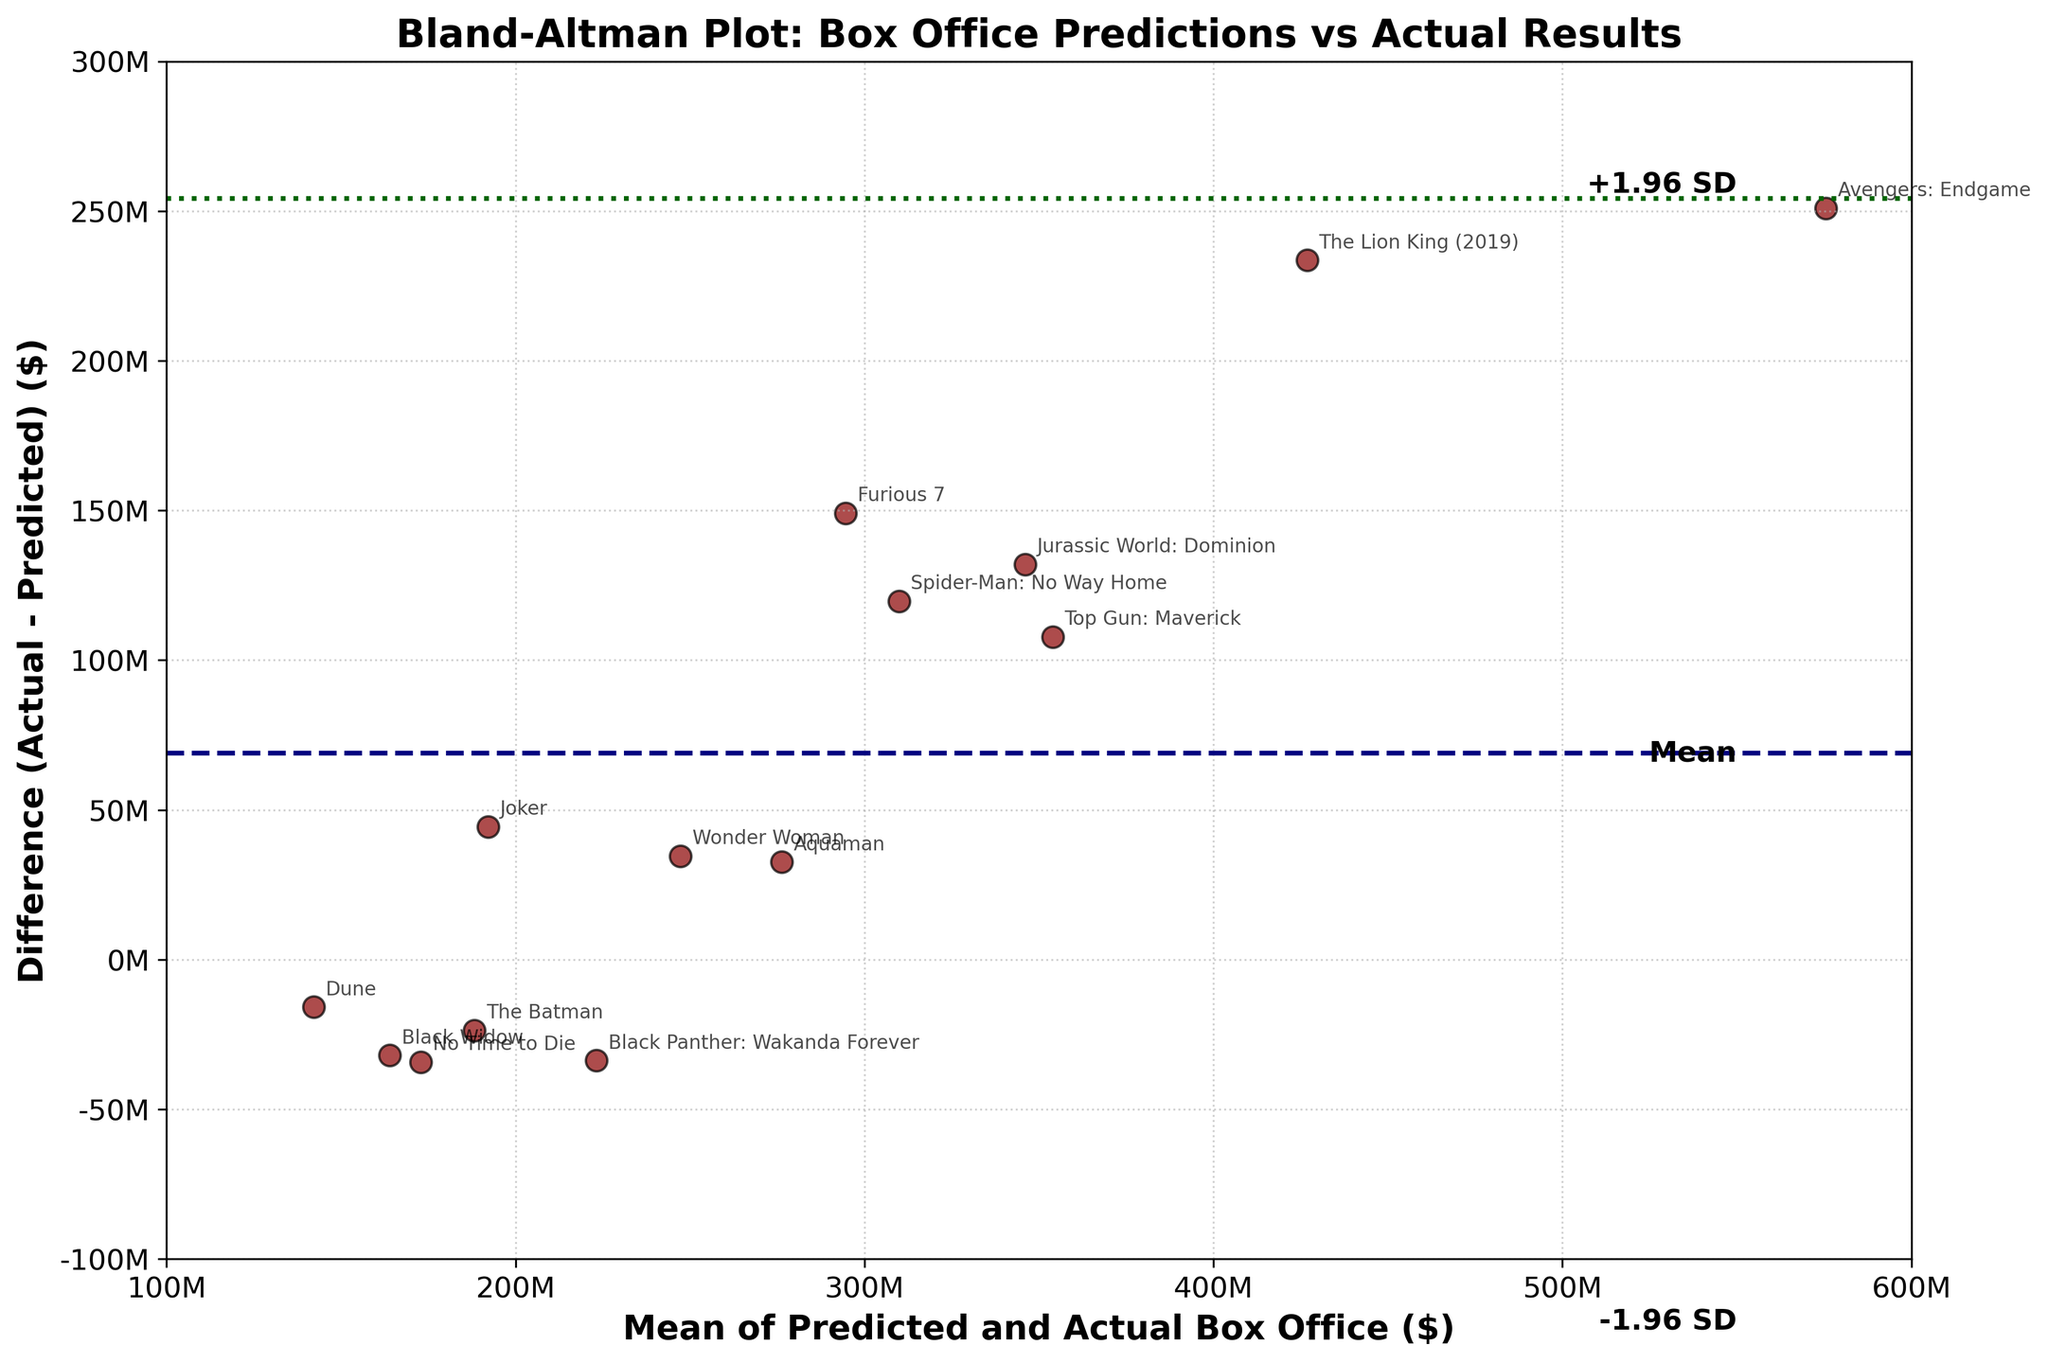What is the title of the figure? The title is located at the top of the figure, which describes what the figure represents. The title reads "Bland-Altman Plot: Box Office Predictions vs Actual Results".
Answer: Bland-Altman Plot: Box Office Predictions vs Actual Results How many movies are represented in the plot? To determine the number of movies, count the distinct scatter points in the plot. Each point represents one movie, and each point is marked with annotations of movie titles.
Answer: 14 What are the units on the x-axis and y-axis? The x-axis represents the mean of predicted and actual box office values, while the y-axis represents the difference between actual and predicted box office values. Both axes use dollars, indicated in millions ($M).
Answer: Dollars (Millions) What is the mean difference between actual and predicted box office performances? The mean difference is indicated by the horizontal navy dashed line in the plot. This line represents the average difference of the data points on the y-axis.
Answer: Approximately 53 million dollars Which movie has the largest positive difference between actual and predicted box office values? Look for the highest scatter point on the plot, as this represents the largest positive difference (actual - predicted). According to the annotation, this movie is "Avengers: Endgame".
Answer: Avengers: Endgame Which movie has the largest negative difference between actual and predicted box office values? Locate the lowest scatter point on the plot which represents the largest negative difference (actual - predicted). From reading the annotations, this movie is "Black Widow".
Answer: Black Widow How many data points lie within the +1.96 SD and -1.96 SD limits? Examine the number of scatter points between the green dotted lines that represent ±1.96 times the standard deviation from the mean difference. Count all the dots falling within these limits.
Answer: 12 What does it signify if a data point is above the green dotted line at +1.96 SD? Points above the +1.96 SD line indicate that for those movies, the actual box office performance significantly exceeded the predicted performance beyond the typical variation represented by the standard deviation.
Answer: Actual exceeds predicted by a significant margin What is the relationship between the mean box office and the actual-predicted difference for 'The Lion King (2019)'? Find the 'The Lion King (2019)' data point, then observe its position relative to both axes. Its mean box office is roughly halfway on the x-axis, while its difference is quite high on the y-axis, indicating the actual box office was much greater than predicted.
Answer: High actual compared to predicted Explain why it is important to include ±1.96 SD limits in a Bland-Altman plot. The ±1.96 SD limits provide context for understanding the typical range of differences between actual and predicted values. They highlight the extent of agreement between the predicted and actual performances, showing where differences are within expected variability versus outliers that point to significant prediction errors.
Answer: To understand typical variability and identify significant prediction errors 